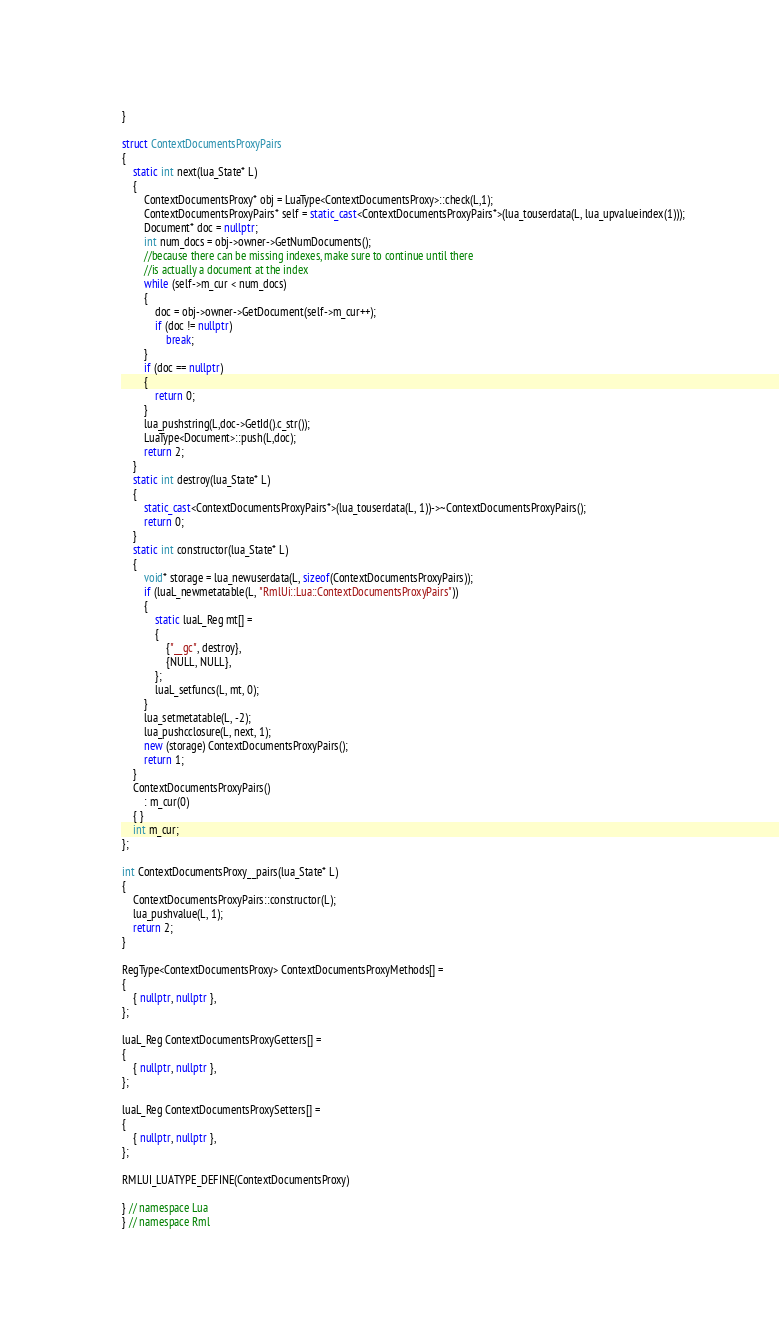<code> <loc_0><loc_0><loc_500><loc_500><_C++_>    
}

struct ContextDocumentsProxyPairs
{
    static int next(lua_State* L) 
    {
        ContextDocumentsProxy* obj = LuaType<ContextDocumentsProxy>::check(L,1);
        ContextDocumentsProxyPairs* self = static_cast<ContextDocumentsProxyPairs*>(lua_touserdata(L, lua_upvalueindex(1)));
        Document* doc = nullptr;
        int num_docs = obj->owner->GetNumDocuments();
        //because there can be missing indexes, make sure to continue until there
        //is actually a document at the index
        while (self->m_cur < num_docs)
        {
            doc = obj->owner->GetDocument(self->m_cur++);
            if (doc != nullptr)
                break;
        }
        if (doc == nullptr)
        {
            return 0;
        }
        lua_pushstring(L,doc->GetId().c_str());
        LuaType<Document>::push(L,doc);
        return 2;
    }
    static int destroy(lua_State* L)
    {
        static_cast<ContextDocumentsProxyPairs*>(lua_touserdata(L, 1))->~ContextDocumentsProxyPairs();
        return 0;
    }
    static int constructor(lua_State* L)
    {
        void* storage = lua_newuserdata(L, sizeof(ContextDocumentsProxyPairs));
        if (luaL_newmetatable(L, "RmlUi::Lua::ContextDocumentsProxyPairs"))
        {
            static luaL_Reg mt[] =
            {
                {"__gc", destroy},
                {NULL, NULL},
            };
            luaL_setfuncs(L, mt, 0);
        }
        lua_setmetatable(L, -2);
        lua_pushcclosure(L, next, 1);
        new (storage) ContextDocumentsProxyPairs();
        return 1;
    }
    ContextDocumentsProxyPairs()
        : m_cur(0)
    { }
    int m_cur;
};

int ContextDocumentsProxy__pairs(lua_State* L)
{
    ContextDocumentsProxyPairs::constructor(L);
    lua_pushvalue(L, 1);
    return 2;
}

RegType<ContextDocumentsProxy> ContextDocumentsProxyMethods[] =
{
    { nullptr, nullptr },
};

luaL_Reg ContextDocumentsProxyGetters[] =
{
    { nullptr, nullptr },
};

luaL_Reg ContextDocumentsProxySetters[] =
{
    { nullptr, nullptr },
};

RMLUI_LUATYPE_DEFINE(ContextDocumentsProxy)

} // namespace Lua
} // namespace Rml
</code> 